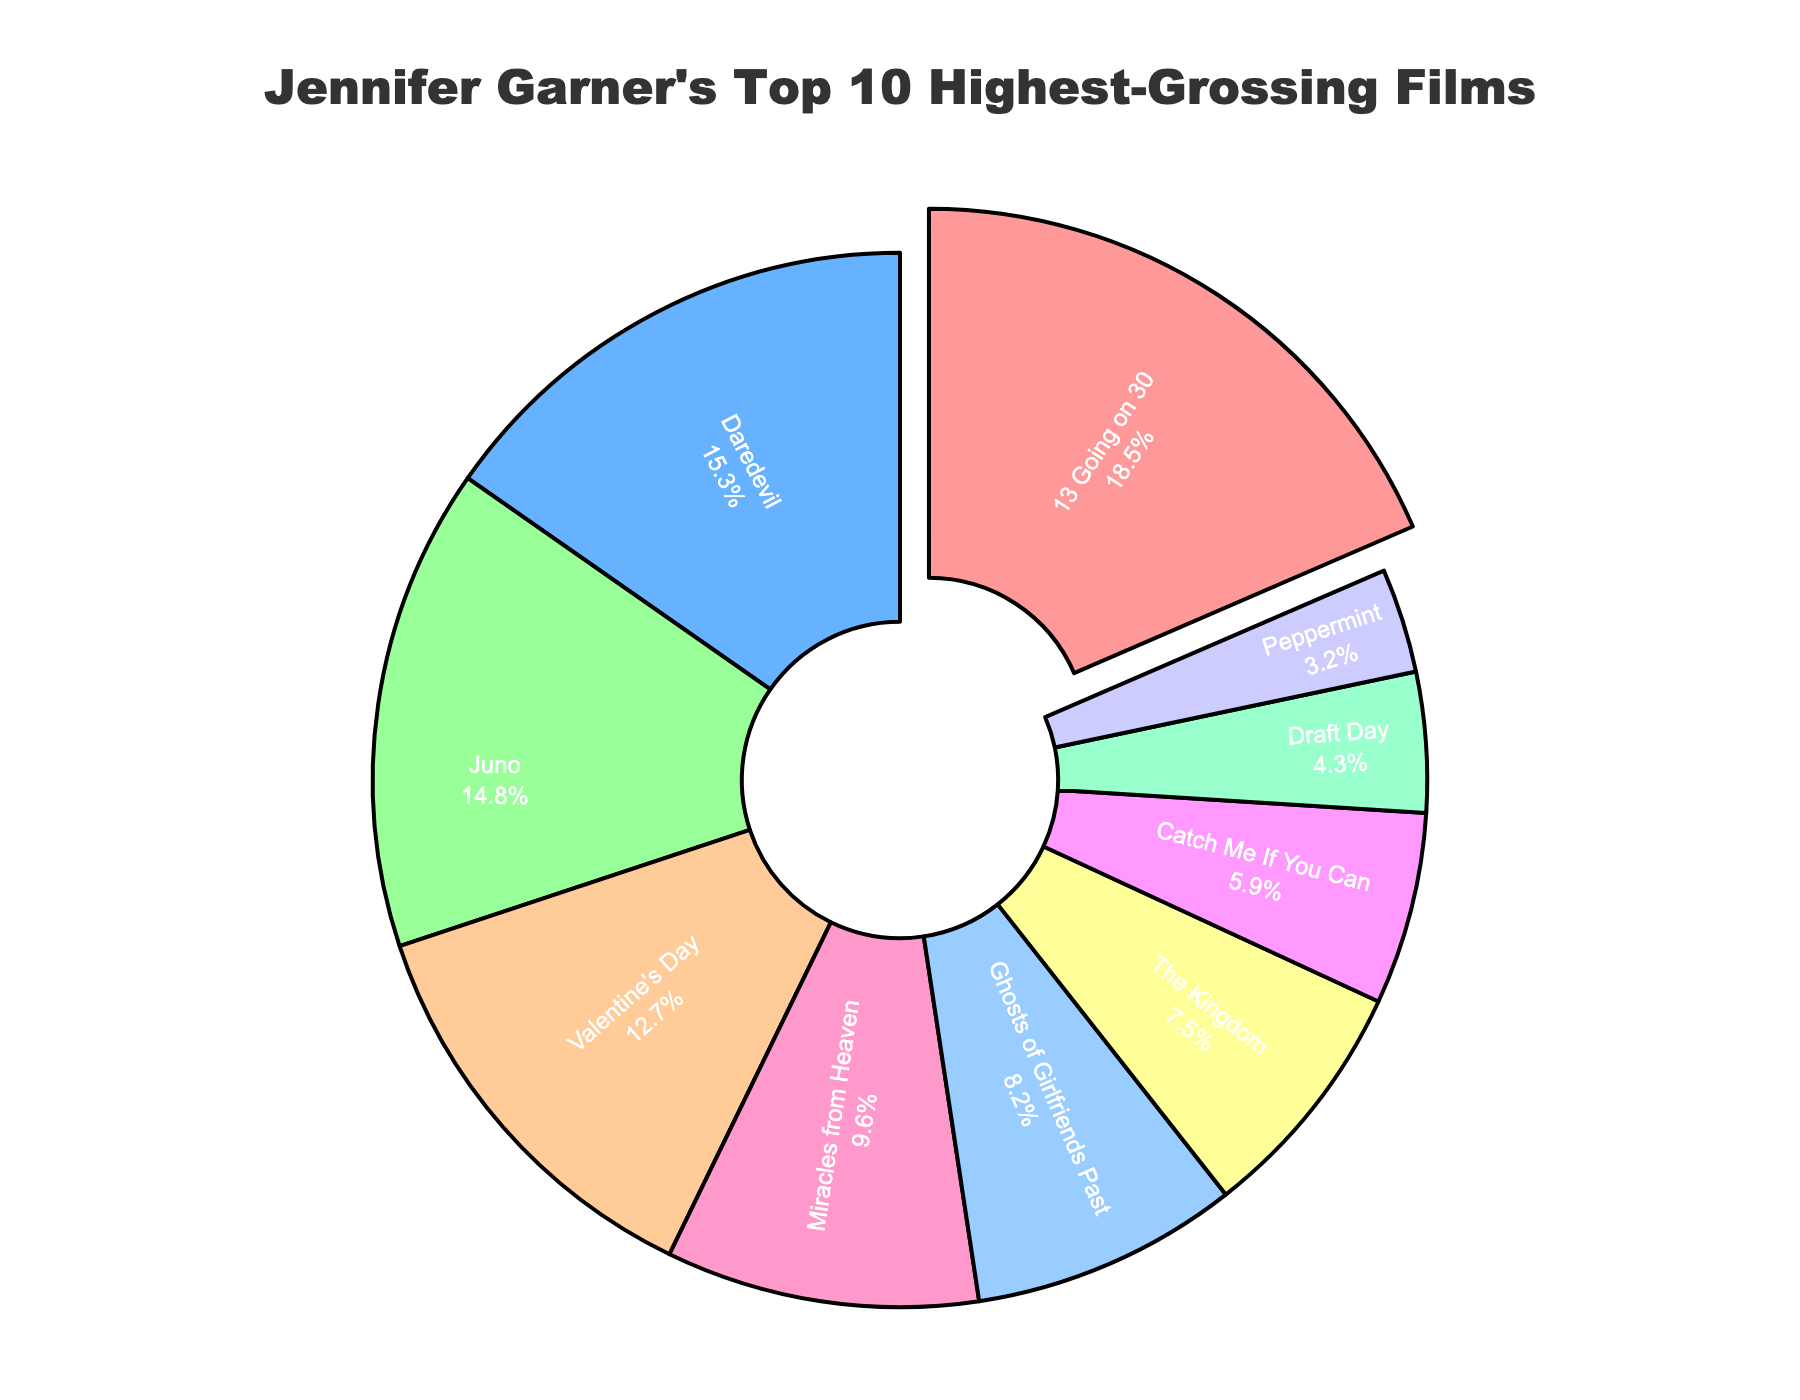What is the highest-grossing film of Jennifer Garner according to the pie chart? The slice pulled out in the pie chart represents the highest-grossing film. The label inside this slice will give the movie title.
Answer: 13 Going on 30 Which film has the lowest box office revenue share? The smallest slice in the pie chart corresponds to the lowest box office revenue share. By finding this smallest slice and reading the label inside it, we can determine the film.
Answer: Peppermint Which film has a higher box office revenue share: The Kingdom or Ghosts of Girlfriends Past? Compare the sizes of the slices for each film. The larger the slice, the higher the revenue share. Ghosts of Girlfriends Past has a larger slice compared to The Kingdom.
Answer: Ghosts of Girlfriends Past If you combine the box office revenue shares of Daredevil and Juno, what is the total share? Add the box office revenue shares of Daredevil (15.3%) and Juno (14.8%). 15.3% + 14.8% = 30.1%
Answer: 30.1% How many films have a box office share above 10%? Count the number of slices that represent more than 10% based on their labels inside each slice. The films above 10% are 13 Going on 30, Daredevil, Juno, and Valentine's Day.
Answer: 4 Which films have a combined box office revenue share that is less than Valentine's Day? Valentine's Day has a share of 12.7%. Summing smaller shares until the total is less than 12.7% involves Miracles from Heaven (9.6%), Ghosts of Girlfriends Past (8.2%), The Kingdom (7.5%), Catch Me If You Can (5.9%), Draft Day (4.3%), and Peppermint (3.2%). Ensure the combination is less than or equal to 12.7%.
Answer: Miracles from Heaven and Ghosts of Girlfriends Past What is the difference in box office revenue share between 13 Going on 30 and Peppermint? Subtract the share of Peppermint (3.2%) from the share of 13 Going on 30 (18.5%). 18.5% - 3.2% = 15.3%
Answer: 15.3% Which films are represented by shades of blue in the pie chart? Identify the slices that are colored blue and read the labels inside them. Only consider shades designated visually. Valentine's Day and Miracles from Heaven have shades of blue.
Answer: Valentine's Day and Miracles from Heaven 